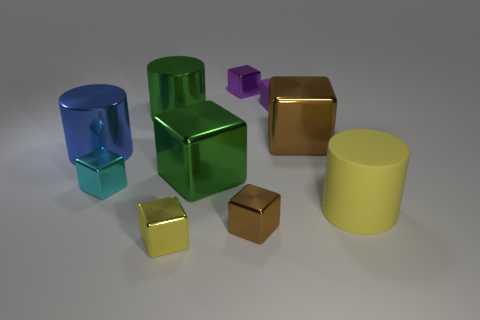How does the lighting in the scene affect the appearance of the objects? The lighting in the scene casts soft shadows and contributes to the glossy appearance of the objects. It accentuates their shapes and the reflective properties of their surfaces. The directional light source seems to come from the upper right, creating highlights which help to define the volume and contours of each object. Could you describe the shadows in more detail, please? Certainly. The shadows are subtle and diffused, suggesting a soft, indirect light source. Each object casts a shadow that is lighter and less defined closer to the base, becoming more distinct and darker as it stretches away. This gradation in the shadows adds depth to the scene and enhances the three-dimensional perception of the objects. 